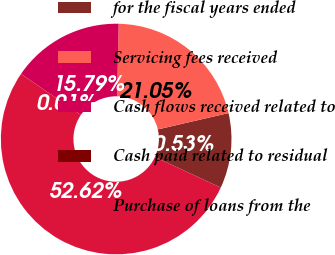Convert chart. <chart><loc_0><loc_0><loc_500><loc_500><pie_chart><fcel>for the fiscal years ended<fcel>Servicing fees received<fcel>Cash flows received related to<fcel>Cash paid related to residual<fcel>Purchase of loans from the<nl><fcel>10.53%<fcel>21.05%<fcel>15.79%<fcel>0.01%<fcel>52.62%<nl></chart> 